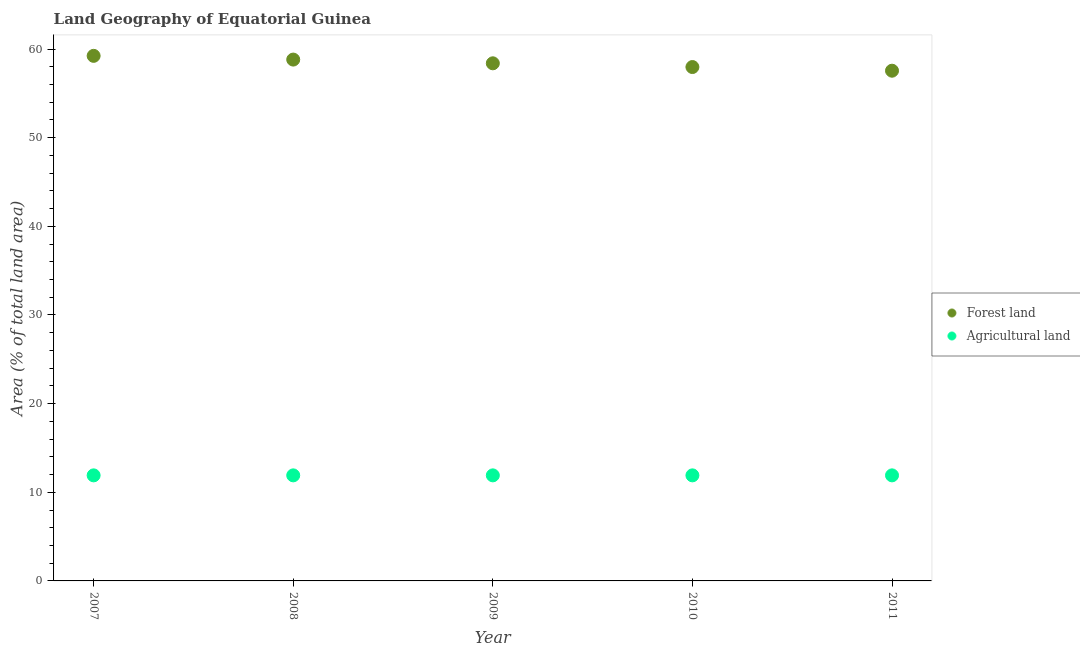How many different coloured dotlines are there?
Your answer should be very brief. 2. What is the percentage of land area under forests in 2010?
Your answer should be compact. 57.97. Across all years, what is the maximum percentage of land area under forests?
Provide a succinct answer. 59.23. Across all years, what is the minimum percentage of land area under forests?
Your answer should be compact. 57.55. In which year was the percentage of land area under forests minimum?
Ensure brevity in your answer.  2011. What is the total percentage of land area under forests in the graph?
Give a very brief answer. 291.95. What is the difference between the percentage of land area under forests in 2007 and that in 2008?
Provide a succinct answer. 0.42. What is the difference between the percentage of land area under agriculture in 2011 and the percentage of land area under forests in 2008?
Offer a very short reply. -46.9. What is the average percentage of land area under forests per year?
Make the answer very short. 58.39. In the year 2010, what is the difference between the percentage of land area under forests and percentage of land area under agriculture?
Offer a very short reply. 46.06. Is the percentage of land area under agriculture in 2008 less than that in 2009?
Give a very brief answer. No. Is the difference between the percentage of land area under forests in 2008 and 2010 greater than the difference between the percentage of land area under agriculture in 2008 and 2010?
Provide a succinct answer. Yes. What is the difference between the highest and the second highest percentage of land area under forests?
Keep it short and to the point. 0.42. What is the difference between the highest and the lowest percentage of land area under forests?
Provide a short and direct response. 1.68. Does the percentage of land area under forests monotonically increase over the years?
Provide a short and direct response. No. Is the percentage of land area under agriculture strictly greater than the percentage of land area under forests over the years?
Your answer should be very brief. No. How many years are there in the graph?
Your response must be concise. 5. Are the values on the major ticks of Y-axis written in scientific E-notation?
Provide a succinct answer. No. Does the graph contain any zero values?
Your response must be concise. No. Does the graph contain grids?
Offer a very short reply. No. How many legend labels are there?
Offer a very short reply. 2. What is the title of the graph?
Make the answer very short. Land Geography of Equatorial Guinea. What is the label or title of the X-axis?
Offer a terse response. Year. What is the label or title of the Y-axis?
Provide a short and direct response. Area (% of total land area). What is the Area (% of total land area) of Forest land in 2007?
Make the answer very short. 59.23. What is the Area (% of total land area) in Agricultural land in 2007?
Offer a very short reply. 11.91. What is the Area (% of total land area) of Forest land in 2008?
Your response must be concise. 58.81. What is the Area (% of total land area) in Agricultural land in 2008?
Your answer should be very brief. 11.91. What is the Area (% of total land area) of Forest land in 2009?
Give a very brief answer. 58.39. What is the Area (% of total land area) in Agricultural land in 2009?
Your answer should be very brief. 11.91. What is the Area (% of total land area) in Forest land in 2010?
Offer a terse response. 57.97. What is the Area (% of total land area) of Agricultural land in 2010?
Ensure brevity in your answer.  11.91. What is the Area (% of total land area) in Forest land in 2011?
Offer a very short reply. 57.55. What is the Area (% of total land area) of Agricultural land in 2011?
Provide a short and direct response. 11.91. Across all years, what is the maximum Area (% of total land area) of Forest land?
Your answer should be compact. 59.23. Across all years, what is the maximum Area (% of total land area) in Agricultural land?
Keep it short and to the point. 11.91. Across all years, what is the minimum Area (% of total land area) in Forest land?
Your answer should be very brief. 57.55. Across all years, what is the minimum Area (% of total land area) of Agricultural land?
Provide a succinct answer. 11.91. What is the total Area (% of total land area) of Forest land in the graph?
Keep it short and to the point. 291.95. What is the total Area (% of total land area) of Agricultural land in the graph?
Keep it short and to the point. 59.54. What is the difference between the Area (% of total land area) in Forest land in 2007 and that in 2008?
Provide a succinct answer. 0.42. What is the difference between the Area (% of total land area) in Forest land in 2007 and that in 2009?
Provide a succinct answer. 0.84. What is the difference between the Area (% of total land area) of Agricultural land in 2007 and that in 2009?
Offer a very short reply. 0. What is the difference between the Area (% of total land area) in Forest land in 2007 and that in 2010?
Provide a succinct answer. 1.26. What is the difference between the Area (% of total land area) of Agricultural land in 2007 and that in 2010?
Your answer should be very brief. 0. What is the difference between the Area (% of total land area) of Forest land in 2007 and that in 2011?
Give a very brief answer. 1.68. What is the difference between the Area (% of total land area) in Agricultural land in 2007 and that in 2011?
Your answer should be compact. 0. What is the difference between the Area (% of total land area) in Forest land in 2008 and that in 2009?
Offer a terse response. 0.42. What is the difference between the Area (% of total land area) in Forest land in 2008 and that in 2010?
Keep it short and to the point. 0.84. What is the difference between the Area (% of total land area) of Agricultural land in 2008 and that in 2010?
Your response must be concise. 0. What is the difference between the Area (% of total land area) in Forest land in 2008 and that in 2011?
Give a very brief answer. 1.25. What is the difference between the Area (% of total land area) of Agricultural land in 2008 and that in 2011?
Give a very brief answer. 0. What is the difference between the Area (% of total land area) in Forest land in 2009 and that in 2010?
Your answer should be compact. 0.42. What is the difference between the Area (% of total land area) in Forest land in 2009 and that in 2011?
Provide a succinct answer. 0.83. What is the difference between the Area (% of total land area) in Agricultural land in 2009 and that in 2011?
Provide a short and direct response. 0. What is the difference between the Area (% of total land area) of Forest land in 2010 and that in 2011?
Make the answer very short. 0.41. What is the difference between the Area (% of total land area) of Agricultural land in 2010 and that in 2011?
Give a very brief answer. 0. What is the difference between the Area (% of total land area) of Forest land in 2007 and the Area (% of total land area) of Agricultural land in 2008?
Your answer should be compact. 47.32. What is the difference between the Area (% of total land area) in Forest land in 2007 and the Area (% of total land area) in Agricultural land in 2009?
Offer a terse response. 47.32. What is the difference between the Area (% of total land area) of Forest land in 2007 and the Area (% of total land area) of Agricultural land in 2010?
Give a very brief answer. 47.32. What is the difference between the Area (% of total land area) of Forest land in 2007 and the Area (% of total land area) of Agricultural land in 2011?
Ensure brevity in your answer.  47.32. What is the difference between the Area (% of total land area) in Forest land in 2008 and the Area (% of total land area) in Agricultural land in 2009?
Your answer should be compact. 46.9. What is the difference between the Area (% of total land area) in Forest land in 2008 and the Area (% of total land area) in Agricultural land in 2010?
Provide a short and direct response. 46.9. What is the difference between the Area (% of total land area) in Forest land in 2008 and the Area (% of total land area) in Agricultural land in 2011?
Give a very brief answer. 46.9. What is the difference between the Area (% of total land area) of Forest land in 2009 and the Area (% of total land area) of Agricultural land in 2010?
Ensure brevity in your answer.  46.48. What is the difference between the Area (% of total land area) in Forest land in 2009 and the Area (% of total land area) in Agricultural land in 2011?
Make the answer very short. 46.48. What is the difference between the Area (% of total land area) of Forest land in 2010 and the Area (% of total land area) of Agricultural land in 2011?
Provide a short and direct response. 46.06. What is the average Area (% of total land area) of Forest land per year?
Give a very brief answer. 58.39. What is the average Area (% of total land area) of Agricultural land per year?
Your answer should be very brief. 11.91. In the year 2007, what is the difference between the Area (% of total land area) of Forest land and Area (% of total land area) of Agricultural land?
Keep it short and to the point. 47.32. In the year 2008, what is the difference between the Area (% of total land area) in Forest land and Area (% of total land area) in Agricultural land?
Offer a very short reply. 46.9. In the year 2009, what is the difference between the Area (% of total land area) in Forest land and Area (% of total land area) in Agricultural land?
Give a very brief answer. 46.48. In the year 2010, what is the difference between the Area (% of total land area) of Forest land and Area (% of total land area) of Agricultural land?
Keep it short and to the point. 46.06. In the year 2011, what is the difference between the Area (% of total land area) in Forest land and Area (% of total land area) in Agricultural land?
Ensure brevity in your answer.  45.65. What is the ratio of the Area (% of total land area) in Agricultural land in 2007 to that in 2008?
Ensure brevity in your answer.  1. What is the ratio of the Area (% of total land area) in Forest land in 2007 to that in 2009?
Keep it short and to the point. 1.01. What is the ratio of the Area (% of total land area) of Forest land in 2007 to that in 2010?
Ensure brevity in your answer.  1.02. What is the ratio of the Area (% of total land area) of Agricultural land in 2007 to that in 2010?
Offer a terse response. 1. What is the ratio of the Area (% of total land area) of Forest land in 2007 to that in 2011?
Keep it short and to the point. 1.03. What is the ratio of the Area (% of total land area) in Forest land in 2008 to that in 2009?
Offer a terse response. 1.01. What is the ratio of the Area (% of total land area) in Forest land in 2008 to that in 2010?
Make the answer very short. 1.01. What is the ratio of the Area (% of total land area) of Forest land in 2008 to that in 2011?
Keep it short and to the point. 1.02. What is the ratio of the Area (% of total land area) in Agricultural land in 2008 to that in 2011?
Give a very brief answer. 1. What is the ratio of the Area (% of total land area) in Forest land in 2009 to that in 2010?
Provide a short and direct response. 1.01. What is the ratio of the Area (% of total land area) of Agricultural land in 2009 to that in 2010?
Your response must be concise. 1. What is the ratio of the Area (% of total land area) in Forest land in 2009 to that in 2011?
Your response must be concise. 1.01. What is the ratio of the Area (% of total land area) of Agricultural land in 2009 to that in 2011?
Give a very brief answer. 1. What is the ratio of the Area (% of total land area) of Forest land in 2010 to that in 2011?
Your response must be concise. 1.01. What is the difference between the highest and the second highest Area (% of total land area) of Forest land?
Your answer should be very brief. 0.42. What is the difference between the highest and the lowest Area (% of total land area) of Forest land?
Your answer should be very brief. 1.68. 